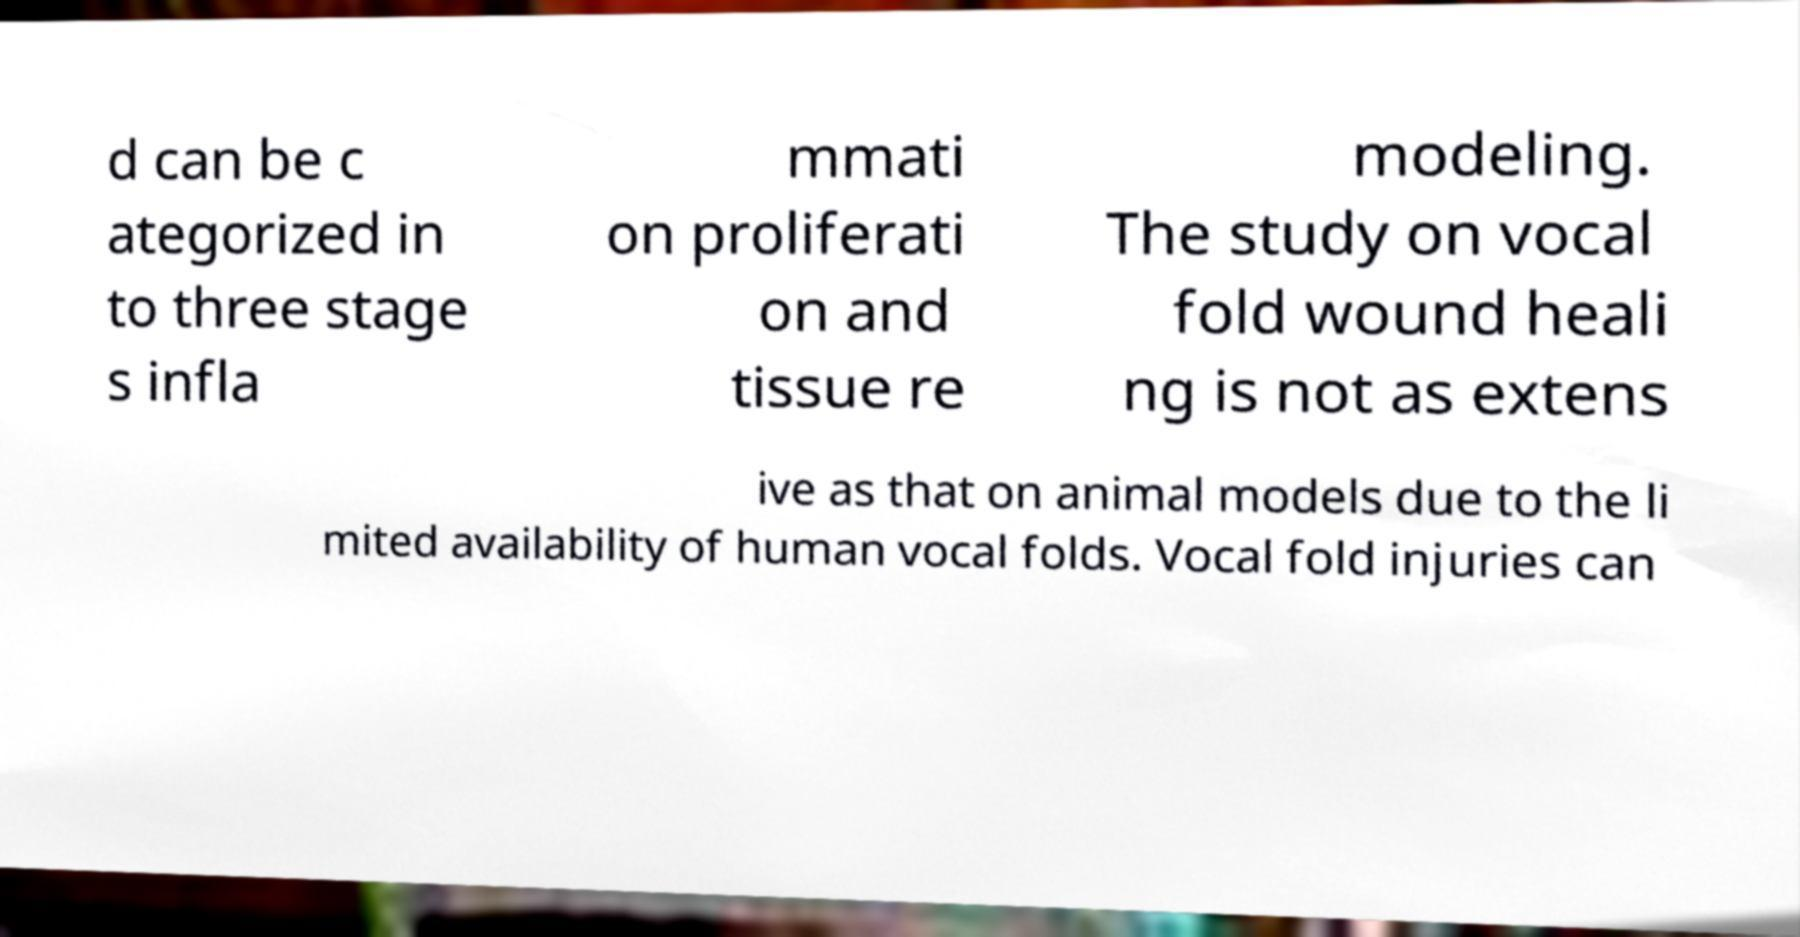For documentation purposes, I need the text within this image transcribed. Could you provide that? d can be c ategorized in to three stage s infla mmati on proliferati on and tissue re modeling. The study on vocal fold wound heali ng is not as extens ive as that on animal models due to the li mited availability of human vocal folds. Vocal fold injuries can 